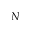<formula> <loc_0><loc_0><loc_500><loc_500>N</formula> 